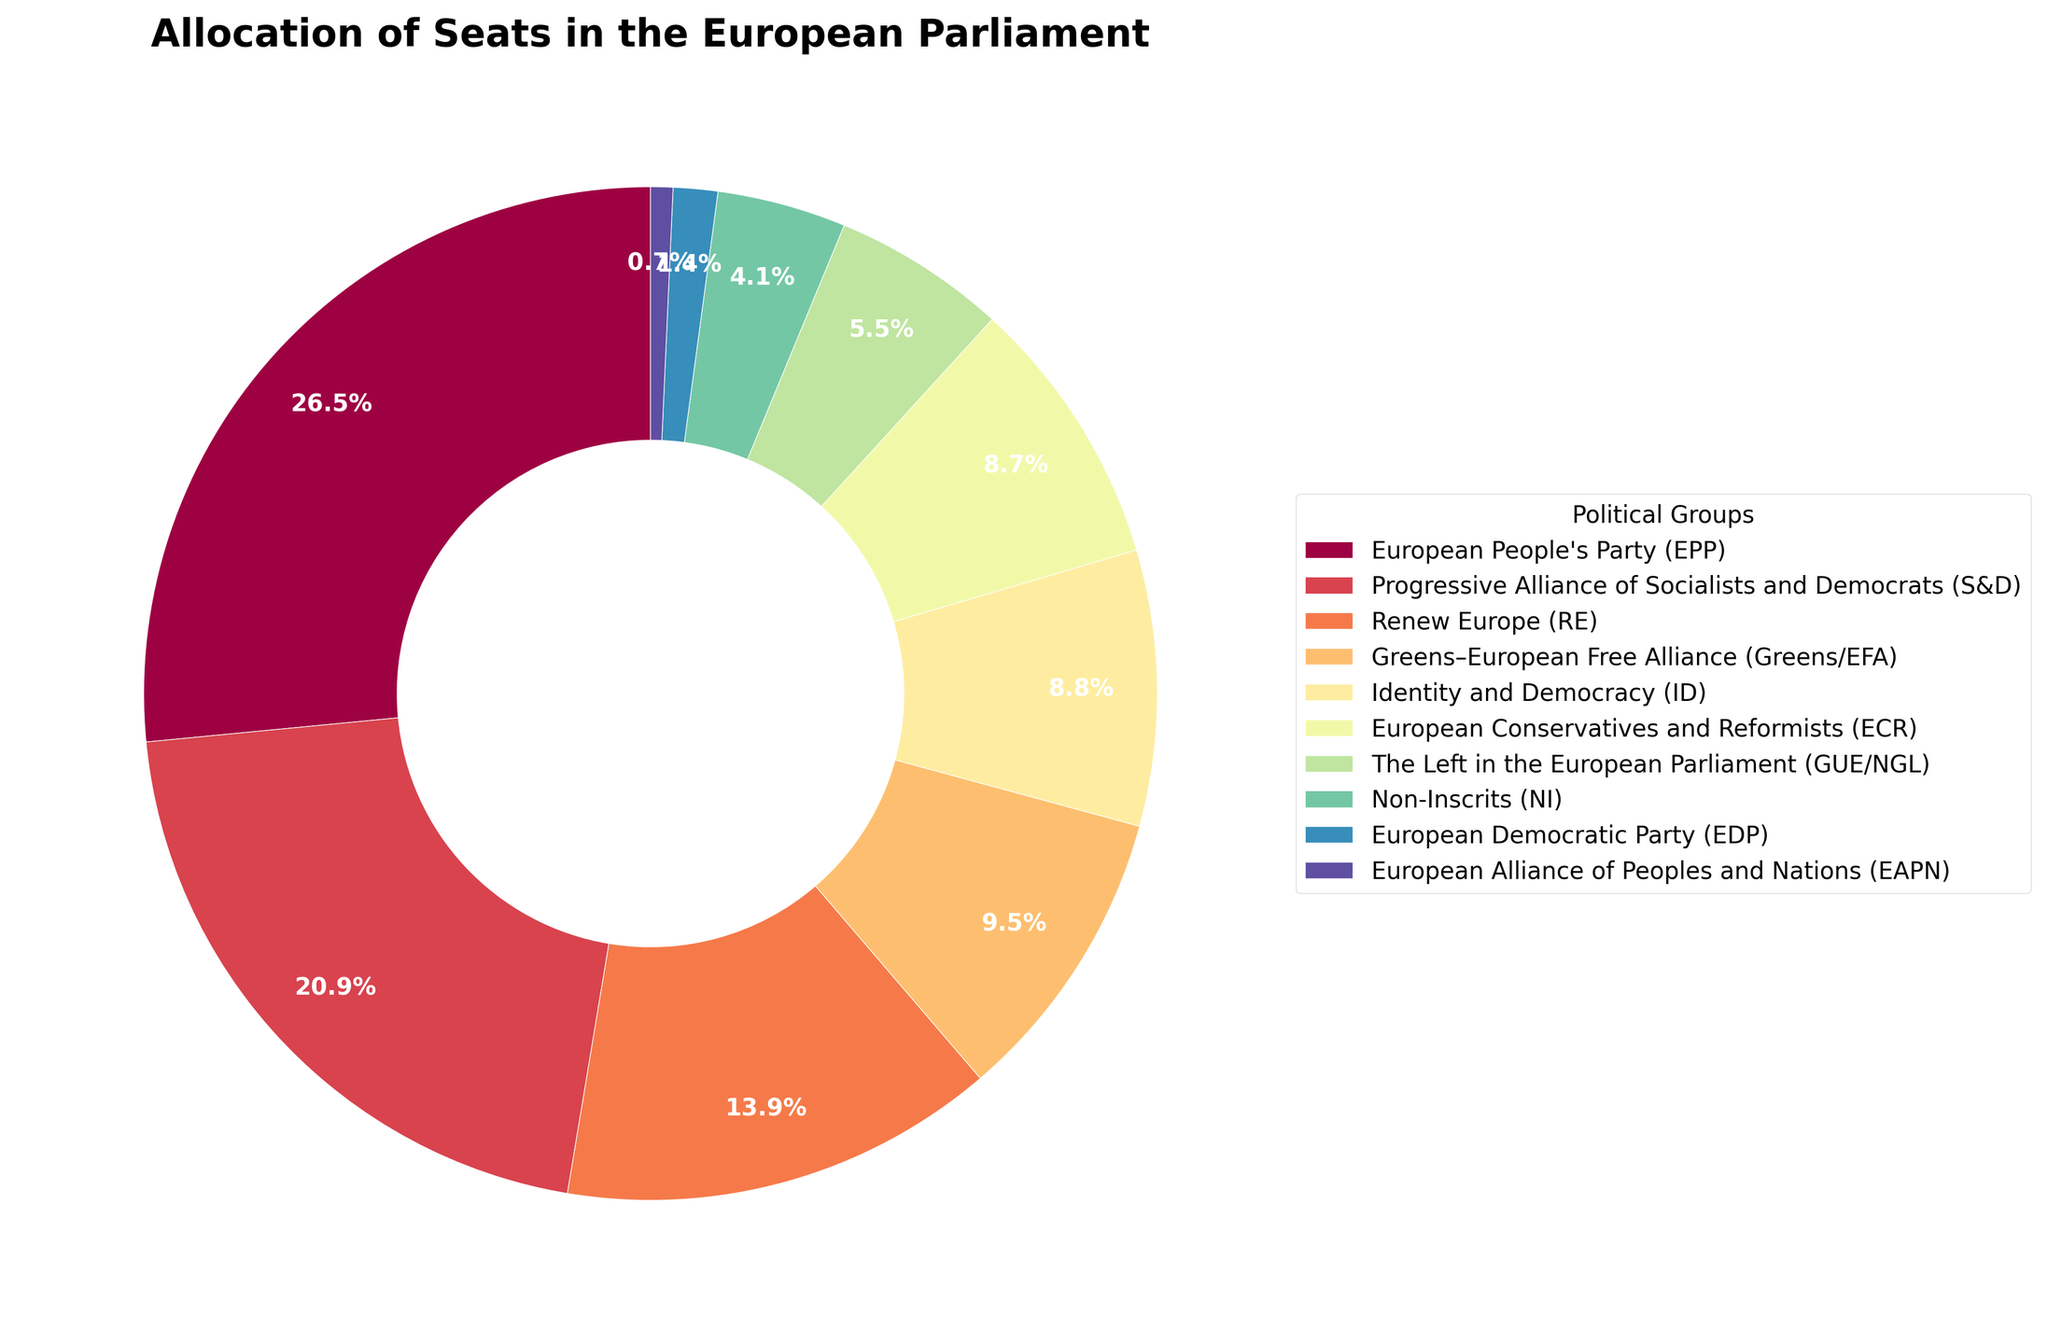What percentage of seats does the European People's Party (EPP) hold? To find the percentage seat allocation for the EPP, refer to the pie chart slice labeled EPP and the accompanying percentage value marked on it.
Answer: 21.9% How many more seats does the Progressive Alliance of Socialists and Democrats (S&D) have than the Identity and Democracy (ID) group? First, find the number of seats for S&D and ID from the chart. The S&D has 147 seats, and ID has 62 seats. Subtract the number of seats held by ID from the number held by S&D: 147 - 62 = 85.
Answer: 85 What's the combined percentage of seats held by Renew Europe (RE) and Greens–European Free Alliance (Greens/EFA)? Find the percentage of seats for both RE and Greens/EFA from the chart. The RE has 11.5%, and Greens/EFA has 7.9%. Add these two percentages: 11.5% + 7.9% = 19.4%.
Answer: 19.4% Which group holds the smallest percentage of seats, and what is that percentage? Identify the smallest slice in the pie chart. The European Alliance of Peoples and Nations (EAPN) has the smallest slice labeled with the percentage.
Answer: EAPN, 0.6% How does the number of seats held by The Left in the European Parliament (GUE/NGL) compare to the number held by the European Conservatives and Reformists (ECR)? From the chart, the GUE/NGL has 39 seats, and ECR has 61 seats. GUE/NGL has fewer seats.
Answer: GUE/NGL has fewer What is the total number of seats represented by the groups that have more than 50 seats each? Identify groups with more than 50 seats: EPP (187), S&D (147), RE (98), and Greens/EFA (67). Sum their seats: 187 + 147 + 98 + 67 = 499.
Answer: 499 Which group has the second-highest number of seats, and how many seats does it have? Locate the group with the second-largest slice after EPP. It's the S&D with 147 seats.
Answer: S&D, 147 What are the colors used to represent Identity and Democracy (ID) and Non-Inscrits (NI)? Refer to the pie chart and locate the colors of their respective slices. The ID group is represented by a specific color, and NI by another.
Answer: ID: red, NI: purple What is the difference in the percentage of seats between the European Conservatives and Reformists (ECR) and The Left in the European Parliament (GUE/NGL)? From the chart, find the percentage seats for ECR and GUE/NGL. ECR has 7.1%, and GUE/NGL has 4.5%. Subtract the smaller percentage from the larger: 7.1% - 4.5% = 2.6%.
Answer: 2.6% 